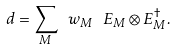<formula> <loc_0><loc_0><loc_500><loc_500>d = \sum _ { M } \ w _ { M } \ E _ { M } \otimes E _ { M } ^ { \dagger } .</formula> 